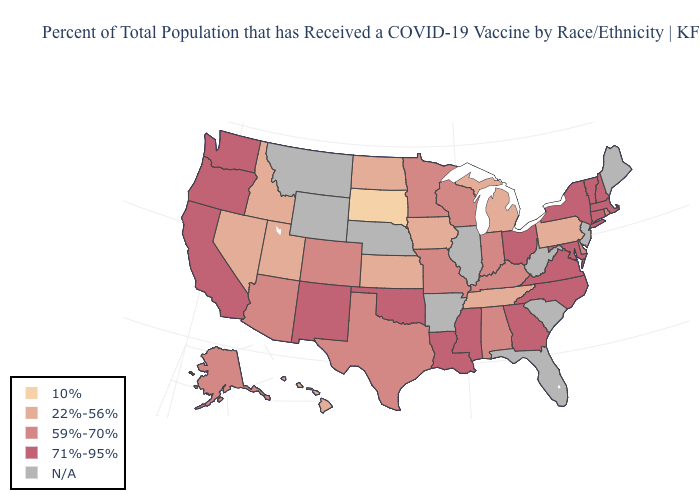Which states have the lowest value in the USA?
Be succinct. South Dakota. What is the value of New York?
Concise answer only. 71%-95%. Name the states that have a value in the range 71%-95%?
Concise answer only. California, Connecticut, Georgia, Louisiana, Maryland, Massachusetts, Mississippi, New Hampshire, New Mexico, New York, North Carolina, Ohio, Oklahoma, Oregon, Vermont, Virginia, Washington. What is the highest value in states that border Maine?
Keep it brief. 71%-95%. Among the states that border New York , does Massachusetts have the lowest value?
Keep it brief. No. What is the value of Arkansas?
Write a very short answer. N/A. Does the map have missing data?
Write a very short answer. Yes. What is the lowest value in the Northeast?
Be succinct. 22%-56%. Does Texas have the highest value in the USA?
Be succinct. No. Among the states that border Massachusetts , which have the highest value?
Be succinct. Connecticut, New Hampshire, New York, Vermont. What is the value of Oklahoma?
Keep it brief. 71%-95%. What is the highest value in states that border Illinois?
Be succinct. 59%-70%. What is the value of Minnesota?
Keep it brief. 59%-70%. What is the highest value in the West ?
Be succinct. 71%-95%. 